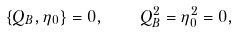<formula> <loc_0><loc_0><loc_500><loc_500>\{ Q _ { B } , \eta _ { 0 } \} = 0 , \quad Q _ { B } ^ { 2 } = \eta _ { 0 } ^ { 2 } = 0 ,</formula> 